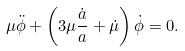Convert formula to latex. <formula><loc_0><loc_0><loc_500><loc_500>\mu \ddot { \phi } + \left ( 3 \mu \frac { \dot { a } } { a } + \dot { \mu } \right ) \dot { \phi } = 0 .</formula> 